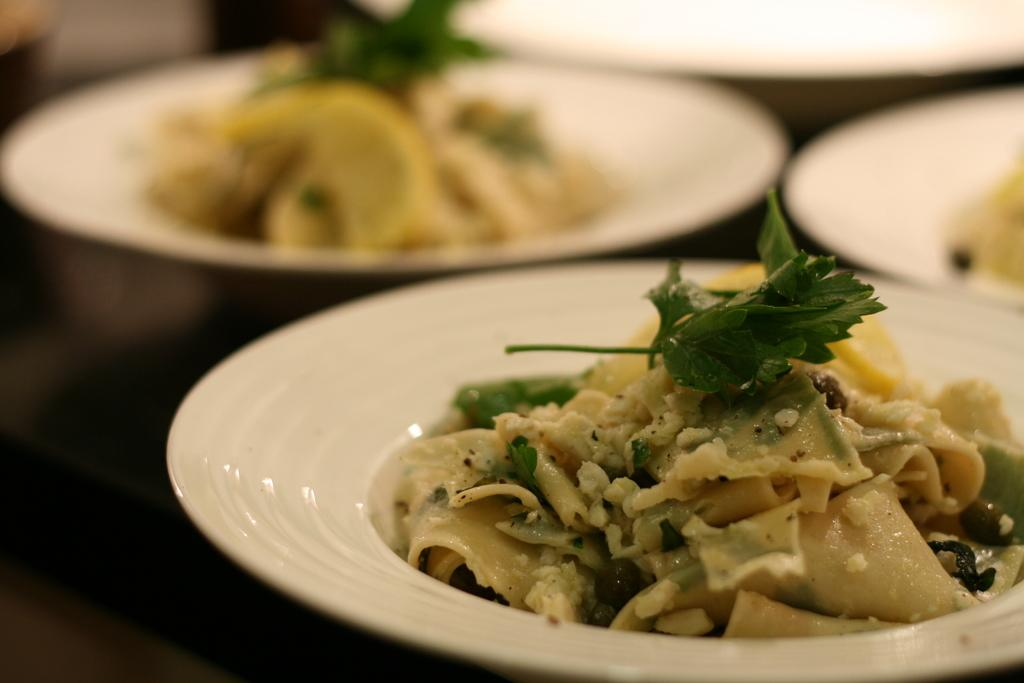What objects are on the table in the image? There are plates on the table in the image. What is on one of the plates? There is a dish on a plate. What type of bait is used to attract animals to the plates in the image? There is no bait present in the image, as the plates contain a dish, not animals. Can you tell me where the pocket is located in the image? There is no pocket present in the image. 